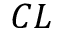<formula> <loc_0><loc_0><loc_500><loc_500>C L</formula> 